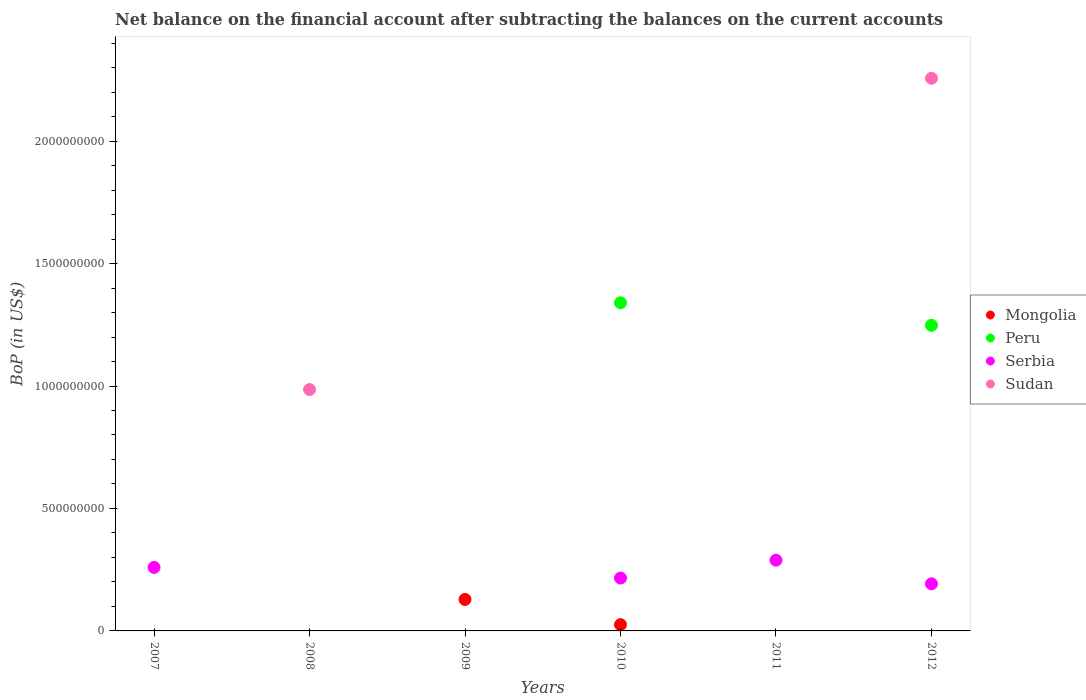Across all years, what is the maximum Balance of Payments in Peru?
Offer a terse response. 1.34e+09. In which year was the Balance of Payments in Serbia maximum?
Your response must be concise. 2011. What is the total Balance of Payments in Mongolia in the graph?
Ensure brevity in your answer.  1.54e+08. What is the difference between the Balance of Payments in Serbia in 2007 and that in 2010?
Keep it short and to the point. 4.34e+07. What is the average Balance of Payments in Sudan per year?
Make the answer very short. 5.40e+08. In the year 2010, what is the difference between the Balance of Payments in Mongolia and Balance of Payments in Serbia?
Your answer should be very brief. -1.90e+08. In how many years, is the Balance of Payments in Peru greater than 600000000 US$?
Make the answer very short. 2. What is the difference between the highest and the second highest Balance of Payments in Serbia?
Provide a succinct answer. 2.96e+07. What is the difference between the highest and the lowest Balance of Payments in Sudan?
Make the answer very short. 2.26e+09. Is it the case that in every year, the sum of the Balance of Payments in Sudan and Balance of Payments in Peru  is greater than the sum of Balance of Payments in Mongolia and Balance of Payments in Serbia?
Provide a short and direct response. No. Does the Balance of Payments in Serbia monotonically increase over the years?
Your answer should be compact. No. Is the Balance of Payments in Peru strictly less than the Balance of Payments in Sudan over the years?
Your response must be concise. No. How many years are there in the graph?
Ensure brevity in your answer.  6. What is the difference between two consecutive major ticks on the Y-axis?
Ensure brevity in your answer.  5.00e+08. Are the values on the major ticks of Y-axis written in scientific E-notation?
Your response must be concise. No. Does the graph contain any zero values?
Offer a terse response. Yes. How many legend labels are there?
Your response must be concise. 4. How are the legend labels stacked?
Your answer should be compact. Vertical. What is the title of the graph?
Offer a terse response. Net balance on the financial account after subtracting the balances on the current accounts. Does "OECD members" appear as one of the legend labels in the graph?
Ensure brevity in your answer.  No. What is the label or title of the X-axis?
Provide a succinct answer. Years. What is the label or title of the Y-axis?
Keep it short and to the point. BoP (in US$). What is the BoP (in US$) of Mongolia in 2007?
Provide a short and direct response. 0. What is the BoP (in US$) of Serbia in 2007?
Your answer should be compact. 2.59e+08. What is the BoP (in US$) of Sudan in 2007?
Your answer should be compact. 0. What is the BoP (in US$) in Mongolia in 2008?
Keep it short and to the point. 0. What is the BoP (in US$) in Sudan in 2008?
Provide a succinct answer. 9.86e+08. What is the BoP (in US$) of Mongolia in 2009?
Offer a very short reply. 1.29e+08. What is the BoP (in US$) of Peru in 2009?
Give a very brief answer. 0. What is the BoP (in US$) in Serbia in 2009?
Make the answer very short. 0. What is the BoP (in US$) of Mongolia in 2010?
Provide a succinct answer. 2.55e+07. What is the BoP (in US$) of Peru in 2010?
Offer a terse response. 1.34e+09. What is the BoP (in US$) in Serbia in 2010?
Offer a terse response. 2.16e+08. What is the BoP (in US$) in Sudan in 2010?
Offer a terse response. 0. What is the BoP (in US$) of Mongolia in 2011?
Provide a short and direct response. 0. What is the BoP (in US$) of Peru in 2011?
Your answer should be very brief. 0. What is the BoP (in US$) in Serbia in 2011?
Your answer should be compact. 2.89e+08. What is the BoP (in US$) in Sudan in 2011?
Keep it short and to the point. 0. What is the BoP (in US$) of Mongolia in 2012?
Provide a short and direct response. 0. What is the BoP (in US$) in Peru in 2012?
Give a very brief answer. 1.25e+09. What is the BoP (in US$) in Serbia in 2012?
Your answer should be very brief. 1.92e+08. What is the BoP (in US$) in Sudan in 2012?
Offer a terse response. 2.26e+09. Across all years, what is the maximum BoP (in US$) of Mongolia?
Give a very brief answer. 1.29e+08. Across all years, what is the maximum BoP (in US$) in Peru?
Give a very brief answer. 1.34e+09. Across all years, what is the maximum BoP (in US$) of Serbia?
Keep it short and to the point. 2.89e+08. Across all years, what is the maximum BoP (in US$) in Sudan?
Ensure brevity in your answer.  2.26e+09. Across all years, what is the minimum BoP (in US$) in Mongolia?
Ensure brevity in your answer.  0. Across all years, what is the minimum BoP (in US$) of Peru?
Make the answer very short. 0. Across all years, what is the minimum BoP (in US$) in Serbia?
Give a very brief answer. 0. What is the total BoP (in US$) in Mongolia in the graph?
Give a very brief answer. 1.54e+08. What is the total BoP (in US$) in Peru in the graph?
Make the answer very short. 2.59e+09. What is the total BoP (in US$) in Serbia in the graph?
Make the answer very short. 9.56e+08. What is the total BoP (in US$) in Sudan in the graph?
Offer a very short reply. 3.24e+09. What is the difference between the BoP (in US$) of Serbia in 2007 and that in 2010?
Make the answer very short. 4.34e+07. What is the difference between the BoP (in US$) in Serbia in 2007 and that in 2011?
Your answer should be very brief. -2.96e+07. What is the difference between the BoP (in US$) of Serbia in 2007 and that in 2012?
Ensure brevity in your answer.  6.69e+07. What is the difference between the BoP (in US$) of Sudan in 2008 and that in 2012?
Ensure brevity in your answer.  -1.27e+09. What is the difference between the BoP (in US$) in Mongolia in 2009 and that in 2010?
Keep it short and to the point. 1.03e+08. What is the difference between the BoP (in US$) of Serbia in 2010 and that in 2011?
Ensure brevity in your answer.  -7.30e+07. What is the difference between the BoP (in US$) in Peru in 2010 and that in 2012?
Give a very brief answer. 9.18e+07. What is the difference between the BoP (in US$) of Serbia in 2010 and that in 2012?
Make the answer very short. 2.35e+07. What is the difference between the BoP (in US$) in Serbia in 2011 and that in 2012?
Provide a succinct answer. 9.65e+07. What is the difference between the BoP (in US$) of Serbia in 2007 and the BoP (in US$) of Sudan in 2008?
Your answer should be very brief. -7.26e+08. What is the difference between the BoP (in US$) of Serbia in 2007 and the BoP (in US$) of Sudan in 2012?
Provide a succinct answer. -2.00e+09. What is the difference between the BoP (in US$) of Mongolia in 2009 and the BoP (in US$) of Peru in 2010?
Make the answer very short. -1.21e+09. What is the difference between the BoP (in US$) of Mongolia in 2009 and the BoP (in US$) of Serbia in 2010?
Provide a short and direct response. -8.73e+07. What is the difference between the BoP (in US$) of Mongolia in 2009 and the BoP (in US$) of Serbia in 2011?
Make the answer very short. -1.60e+08. What is the difference between the BoP (in US$) in Mongolia in 2009 and the BoP (in US$) in Peru in 2012?
Offer a very short reply. -1.12e+09. What is the difference between the BoP (in US$) of Mongolia in 2009 and the BoP (in US$) of Serbia in 2012?
Your answer should be compact. -6.38e+07. What is the difference between the BoP (in US$) in Mongolia in 2009 and the BoP (in US$) in Sudan in 2012?
Provide a succinct answer. -2.13e+09. What is the difference between the BoP (in US$) of Mongolia in 2010 and the BoP (in US$) of Serbia in 2011?
Ensure brevity in your answer.  -2.63e+08. What is the difference between the BoP (in US$) of Peru in 2010 and the BoP (in US$) of Serbia in 2011?
Ensure brevity in your answer.  1.05e+09. What is the difference between the BoP (in US$) in Mongolia in 2010 and the BoP (in US$) in Peru in 2012?
Make the answer very short. -1.22e+09. What is the difference between the BoP (in US$) of Mongolia in 2010 and the BoP (in US$) of Serbia in 2012?
Ensure brevity in your answer.  -1.67e+08. What is the difference between the BoP (in US$) in Mongolia in 2010 and the BoP (in US$) in Sudan in 2012?
Provide a short and direct response. -2.23e+09. What is the difference between the BoP (in US$) of Peru in 2010 and the BoP (in US$) of Serbia in 2012?
Keep it short and to the point. 1.15e+09. What is the difference between the BoP (in US$) in Peru in 2010 and the BoP (in US$) in Sudan in 2012?
Your response must be concise. -9.17e+08. What is the difference between the BoP (in US$) of Serbia in 2010 and the BoP (in US$) of Sudan in 2012?
Ensure brevity in your answer.  -2.04e+09. What is the difference between the BoP (in US$) of Serbia in 2011 and the BoP (in US$) of Sudan in 2012?
Keep it short and to the point. -1.97e+09. What is the average BoP (in US$) of Mongolia per year?
Your answer should be compact. 2.57e+07. What is the average BoP (in US$) in Peru per year?
Your answer should be compact. 4.31e+08. What is the average BoP (in US$) in Serbia per year?
Offer a terse response. 1.59e+08. What is the average BoP (in US$) of Sudan per year?
Provide a short and direct response. 5.40e+08. In the year 2010, what is the difference between the BoP (in US$) of Mongolia and BoP (in US$) of Peru?
Your answer should be compact. -1.31e+09. In the year 2010, what is the difference between the BoP (in US$) in Mongolia and BoP (in US$) in Serbia?
Keep it short and to the point. -1.90e+08. In the year 2010, what is the difference between the BoP (in US$) of Peru and BoP (in US$) of Serbia?
Offer a terse response. 1.12e+09. In the year 2012, what is the difference between the BoP (in US$) in Peru and BoP (in US$) in Serbia?
Provide a succinct answer. 1.06e+09. In the year 2012, what is the difference between the BoP (in US$) in Peru and BoP (in US$) in Sudan?
Your response must be concise. -1.01e+09. In the year 2012, what is the difference between the BoP (in US$) in Serbia and BoP (in US$) in Sudan?
Ensure brevity in your answer.  -2.06e+09. What is the ratio of the BoP (in US$) in Serbia in 2007 to that in 2010?
Offer a very short reply. 1.2. What is the ratio of the BoP (in US$) in Serbia in 2007 to that in 2011?
Provide a succinct answer. 0.9. What is the ratio of the BoP (in US$) of Serbia in 2007 to that in 2012?
Make the answer very short. 1.35. What is the ratio of the BoP (in US$) of Sudan in 2008 to that in 2012?
Your answer should be compact. 0.44. What is the ratio of the BoP (in US$) in Mongolia in 2009 to that in 2010?
Offer a very short reply. 5.03. What is the ratio of the BoP (in US$) of Serbia in 2010 to that in 2011?
Keep it short and to the point. 0.75. What is the ratio of the BoP (in US$) of Peru in 2010 to that in 2012?
Offer a terse response. 1.07. What is the ratio of the BoP (in US$) of Serbia in 2010 to that in 2012?
Give a very brief answer. 1.12. What is the ratio of the BoP (in US$) in Serbia in 2011 to that in 2012?
Provide a succinct answer. 1.5. What is the difference between the highest and the second highest BoP (in US$) of Serbia?
Give a very brief answer. 2.96e+07. What is the difference between the highest and the lowest BoP (in US$) of Mongolia?
Offer a terse response. 1.29e+08. What is the difference between the highest and the lowest BoP (in US$) of Peru?
Your answer should be compact. 1.34e+09. What is the difference between the highest and the lowest BoP (in US$) in Serbia?
Keep it short and to the point. 2.89e+08. What is the difference between the highest and the lowest BoP (in US$) in Sudan?
Provide a succinct answer. 2.26e+09. 